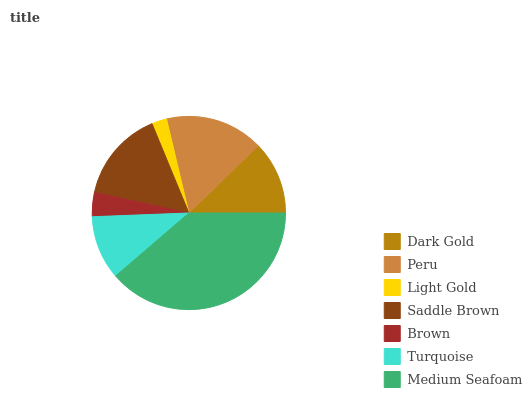Is Light Gold the minimum?
Answer yes or no. Yes. Is Medium Seafoam the maximum?
Answer yes or no. Yes. Is Peru the minimum?
Answer yes or no. No. Is Peru the maximum?
Answer yes or no. No. Is Peru greater than Dark Gold?
Answer yes or no. Yes. Is Dark Gold less than Peru?
Answer yes or no. Yes. Is Dark Gold greater than Peru?
Answer yes or no. No. Is Peru less than Dark Gold?
Answer yes or no. No. Is Dark Gold the high median?
Answer yes or no. Yes. Is Dark Gold the low median?
Answer yes or no. Yes. Is Turquoise the high median?
Answer yes or no. No. Is Saddle Brown the low median?
Answer yes or no. No. 